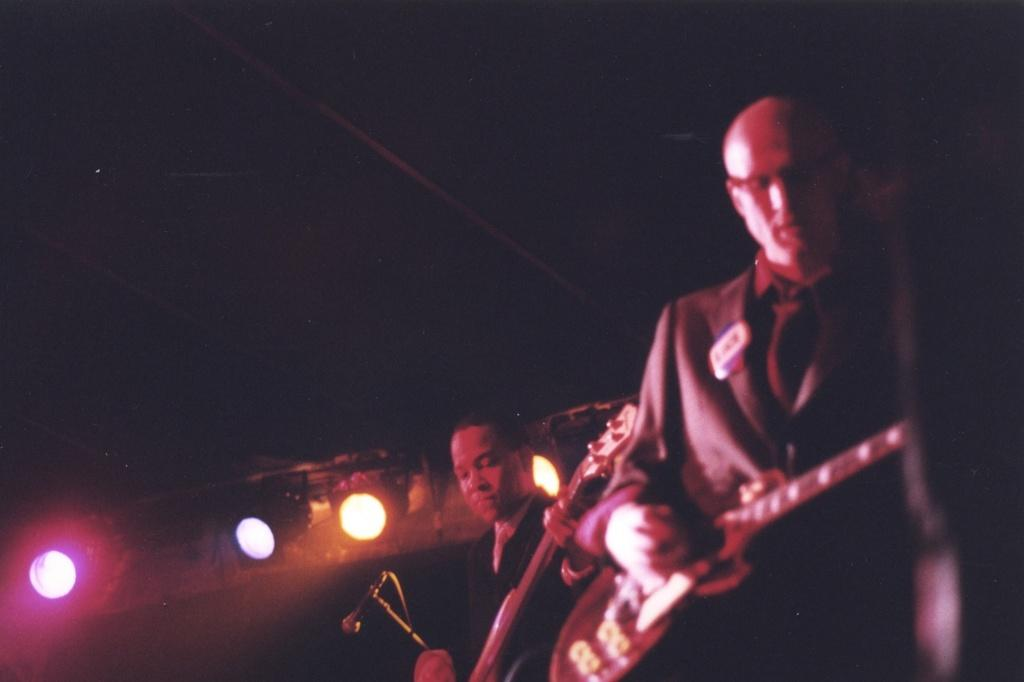How many people are in the image? There are two persons in the image. What are the two persons holding? The two persons are holding a guitar. What can be seen in the image that might be used for illumination? There are focusing lights in the image. What is used for amplifying sound in the image? There is a mic in the image. What is used to hold the mic in the image? There is a mic holder in the image. Where is the sofa located in the image? There is no sofa present in the image. What type of flowers can be seen growing near the mic holder? There are no flowers present in the image. 